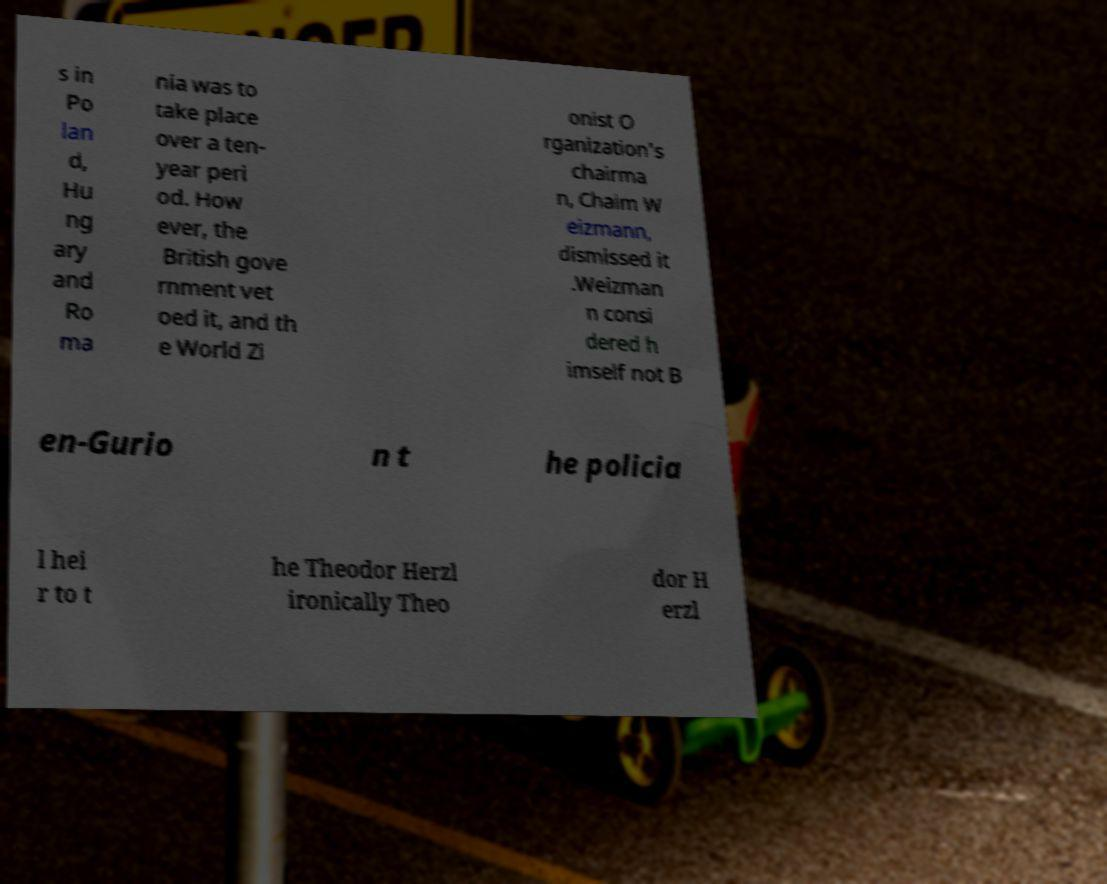Can you read and provide the text displayed in the image?This photo seems to have some interesting text. Can you extract and type it out for me? s in Po lan d, Hu ng ary and Ro ma nia was to take place over a ten- year peri od. How ever, the British gove rnment vet oed it, and th e World Zi onist O rganization's chairma n, Chaim W eizmann, dismissed it .Weizman n consi dered h imself not B en-Gurio n t he policia l hei r to t he Theodor Herzl ironically Theo dor H erzl 